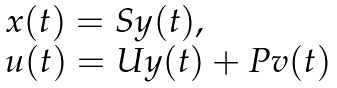Convert formula to latex. <formula><loc_0><loc_0><loc_500><loc_500>\begin{array} { l } x ( t ) = S y ( t ) , \\ u ( t ) = U y ( t ) + P v ( t ) \end{array}</formula> 